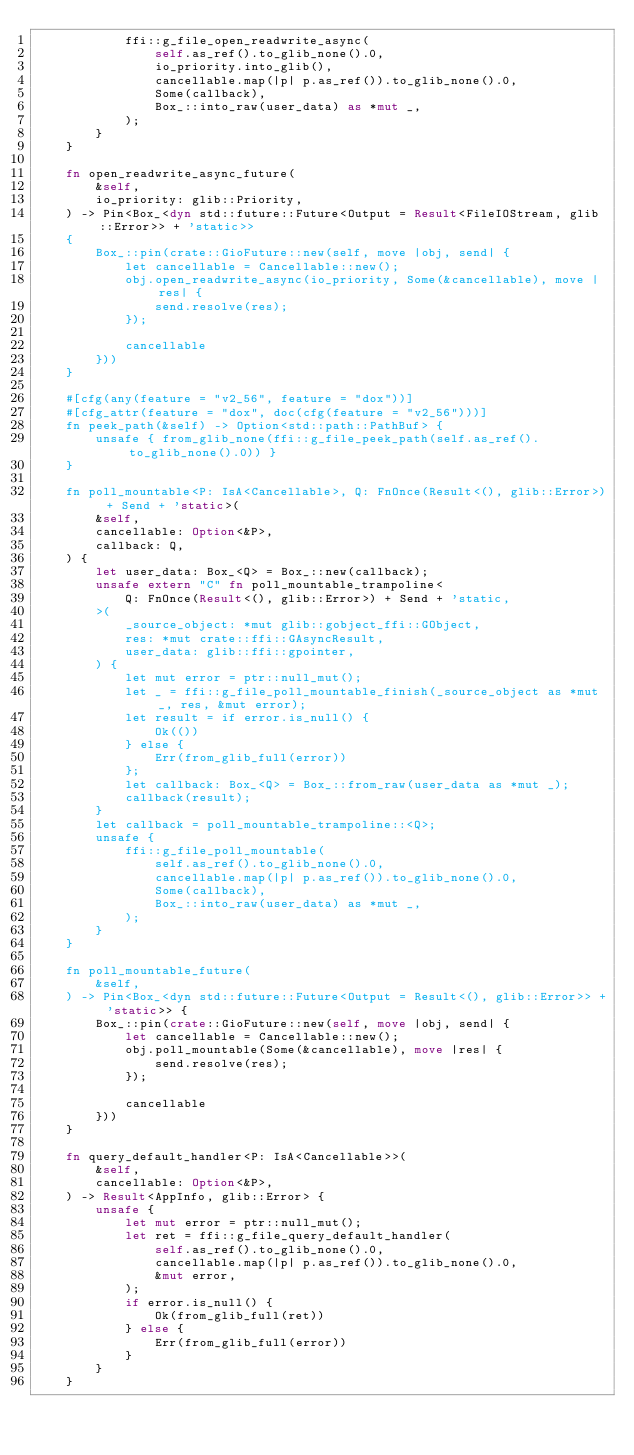<code> <loc_0><loc_0><loc_500><loc_500><_Rust_>            ffi::g_file_open_readwrite_async(
                self.as_ref().to_glib_none().0,
                io_priority.into_glib(),
                cancellable.map(|p| p.as_ref()).to_glib_none().0,
                Some(callback),
                Box_::into_raw(user_data) as *mut _,
            );
        }
    }

    fn open_readwrite_async_future(
        &self,
        io_priority: glib::Priority,
    ) -> Pin<Box_<dyn std::future::Future<Output = Result<FileIOStream, glib::Error>> + 'static>>
    {
        Box_::pin(crate::GioFuture::new(self, move |obj, send| {
            let cancellable = Cancellable::new();
            obj.open_readwrite_async(io_priority, Some(&cancellable), move |res| {
                send.resolve(res);
            });

            cancellable
        }))
    }

    #[cfg(any(feature = "v2_56", feature = "dox"))]
    #[cfg_attr(feature = "dox", doc(cfg(feature = "v2_56")))]
    fn peek_path(&self) -> Option<std::path::PathBuf> {
        unsafe { from_glib_none(ffi::g_file_peek_path(self.as_ref().to_glib_none().0)) }
    }

    fn poll_mountable<P: IsA<Cancellable>, Q: FnOnce(Result<(), glib::Error>) + Send + 'static>(
        &self,
        cancellable: Option<&P>,
        callback: Q,
    ) {
        let user_data: Box_<Q> = Box_::new(callback);
        unsafe extern "C" fn poll_mountable_trampoline<
            Q: FnOnce(Result<(), glib::Error>) + Send + 'static,
        >(
            _source_object: *mut glib::gobject_ffi::GObject,
            res: *mut crate::ffi::GAsyncResult,
            user_data: glib::ffi::gpointer,
        ) {
            let mut error = ptr::null_mut();
            let _ = ffi::g_file_poll_mountable_finish(_source_object as *mut _, res, &mut error);
            let result = if error.is_null() {
                Ok(())
            } else {
                Err(from_glib_full(error))
            };
            let callback: Box_<Q> = Box_::from_raw(user_data as *mut _);
            callback(result);
        }
        let callback = poll_mountable_trampoline::<Q>;
        unsafe {
            ffi::g_file_poll_mountable(
                self.as_ref().to_glib_none().0,
                cancellable.map(|p| p.as_ref()).to_glib_none().0,
                Some(callback),
                Box_::into_raw(user_data) as *mut _,
            );
        }
    }

    fn poll_mountable_future(
        &self,
    ) -> Pin<Box_<dyn std::future::Future<Output = Result<(), glib::Error>> + 'static>> {
        Box_::pin(crate::GioFuture::new(self, move |obj, send| {
            let cancellable = Cancellable::new();
            obj.poll_mountable(Some(&cancellable), move |res| {
                send.resolve(res);
            });

            cancellable
        }))
    }

    fn query_default_handler<P: IsA<Cancellable>>(
        &self,
        cancellable: Option<&P>,
    ) -> Result<AppInfo, glib::Error> {
        unsafe {
            let mut error = ptr::null_mut();
            let ret = ffi::g_file_query_default_handler(
                self.as_ref().to_glib_none().0,
                cancellable.map(|p| p.as_ref()).to_glib_none().0,
                &mut error,
            );
            if error.is_null() {
                Ok(from_glib_full(ret))
            } else {
                Err(from_glib_full(error))
            }
        }
    }
</code> 